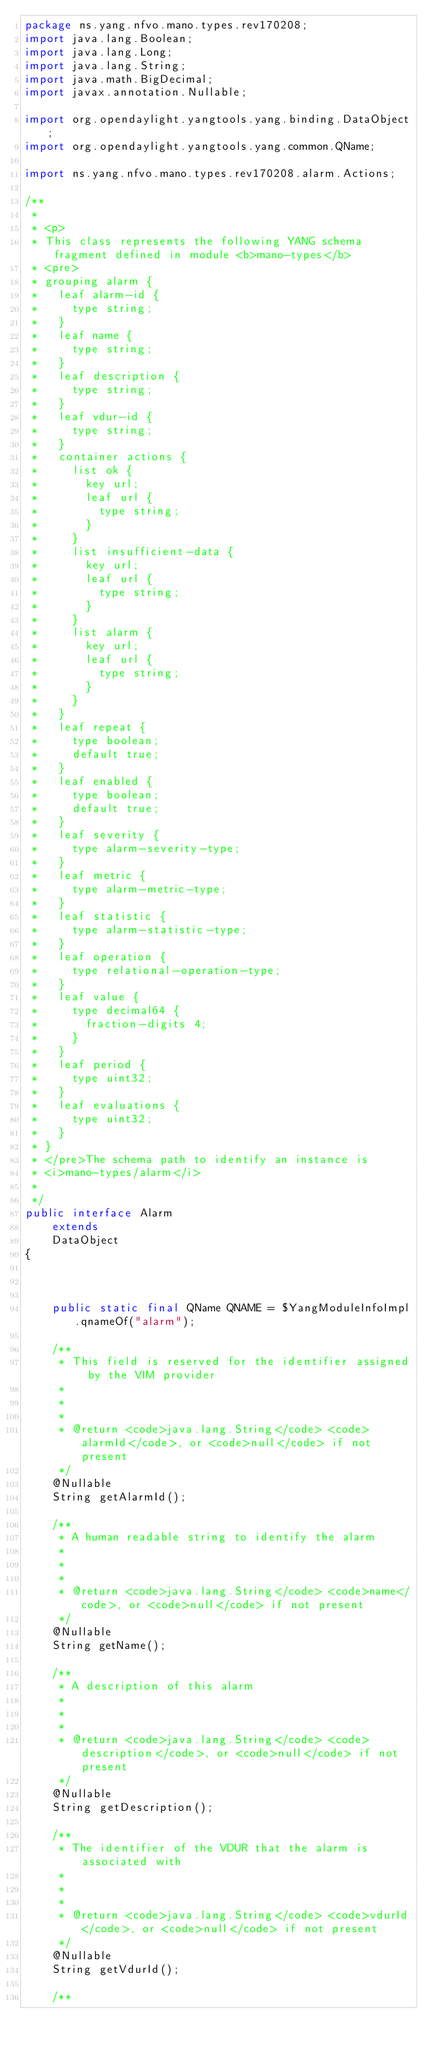<code> <loc_0><loc_0><loc_500><loc_500><_Java_>package ns.yang.nfvo.mano.types.rev170208;
import java.lang.Boolean;
import java.lang.Long;
import java.lang.String;
import java.math.BigDecimal;
import javax.annotation.Nullable;

import org.opendaylight.yangtools.yang.binding.DataObject;
import org.opendaylight.yangtools.yang.common.QName;

import ns.yang.nfvo.mano.types.rev170208.alarm.Actions;

/**
 * 
 * <p>
 * This class represents the following YANG schema fragment defined in module <b>mano-types</b>
 * <pre>
 * grouping alarm {
 *   leaf alarm-id {
 *     type string;
 *   }
 *   leaf name {
 *     type string;
 *   }
 *   leaf description {
 *     type string;
 *   }
 *   leaf vdur-id {
 *     type string;
 *   }
 *   container actions {
 *     list ok {
 *       key url;
 *       leaf url {
 *         type string;
 *       }
 *     }
 *     list insufficient-data {
 *       key url;
 *       leaf url {
 *         type string;
 *       }
 *     }
 *     list alarm {
 *       key url;
 *       leaf url {
 *         type string;
 *       }
 *     }
 *   }
 *   leaf repeat {
 *     type boolean;
 *     default true;
 *   }
 *   leaf enabled {
 *     type boolean;
 *     default true;
 *   }
 *   leaf severity {
 *     type alarm-severity-type;
 *   }
 *   leaf metric {
 *     type alarm-metric-type;
 *   }
 *   leaf statistic {
 *     type alarm-statistic-type;
 *   }
 *   leaf operation {
 *     type relational-operation-type;
 *   }
 *   leaf value {
 *     type decimal64 {
 *       fraction-digits 4;
 *     }
 *   }
 *   leaf period {
 *     type uint32;
 *   }
 *   leaf evaluations {
 *     type uint32;
 *   }
 * }
 * </pre>The schema path to identify an instance is
 * <i>mano-types/alarm</i>
 *
 */
public interface Alarm
    extends
    DataObject
{



    public static final QName QNAME = $YangModuleInfoImpl.qnameOf("alarm");

    /**
     * This field is reserved for the identifier assigned by the VIM provider
     *
     *
     *
     * @return <code>java.lang.String</code> <code>alarmId</code>, or <code>null</code> if not present
     */
    @Nullable
    String getAlarmId();
    
    /**
     * A human readable string to identify the alarm
     *
     *
     *
     * @return <code>java.lang.String</code> <code>name</code>, or <code>null</code> if not present
     */
    @Nullable
    String getName();
    
    /**
     * A description of this alarm
     *
     *
     *
     * @return <code>java.lang.String</code> <code>description</code>, or <code>null</code> if not present
     */
    @Nullable
    String getDescription();
    
    /**
     * The identifier of the VDUR that the alarm is associated with
     *
     *
     *
     * @return <code>java.lang.String</code> <code>vdurId</code>, or <code>null</code> if not present
     */
    @Nullable
    String getVdurId();
    
    /**</code> 